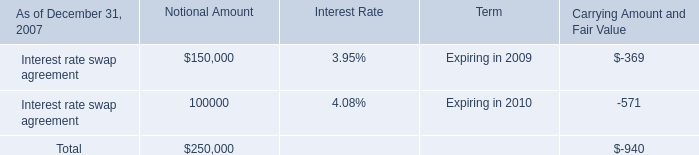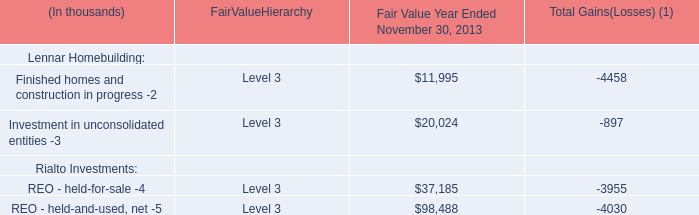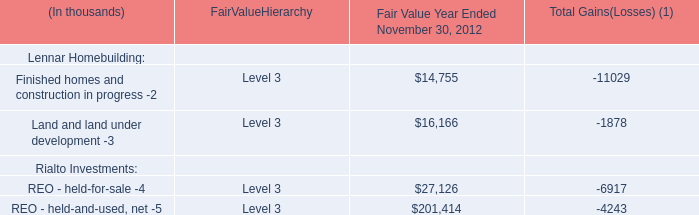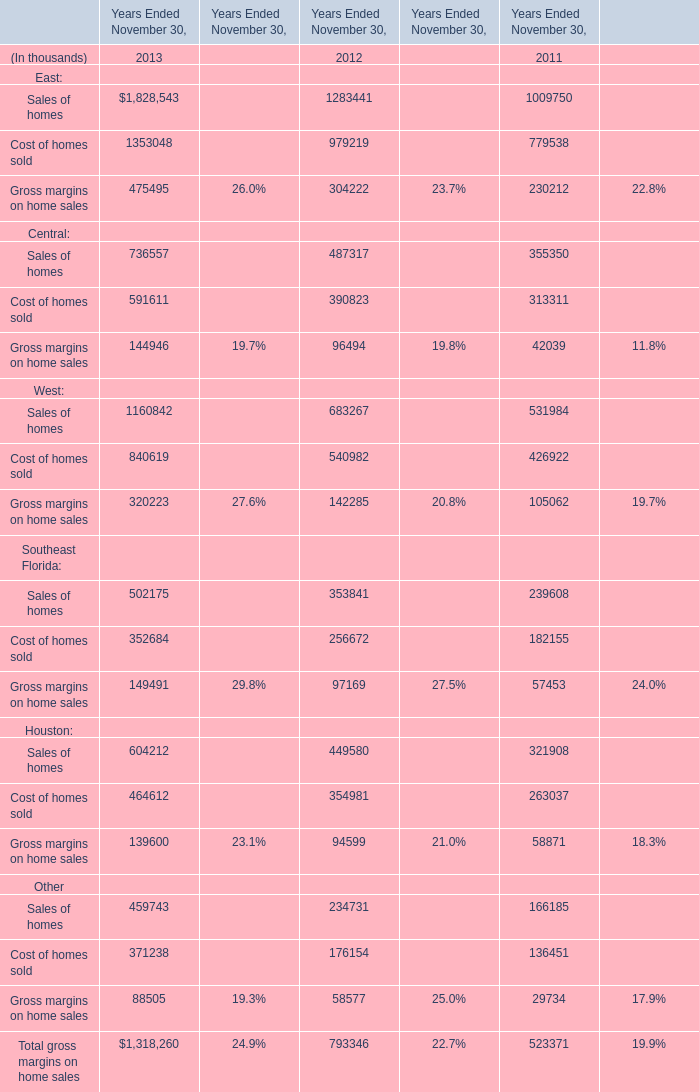Which year is Total gross margins on home sales the most,in terms of Years Ended November 30? 
Answer: 2013. 